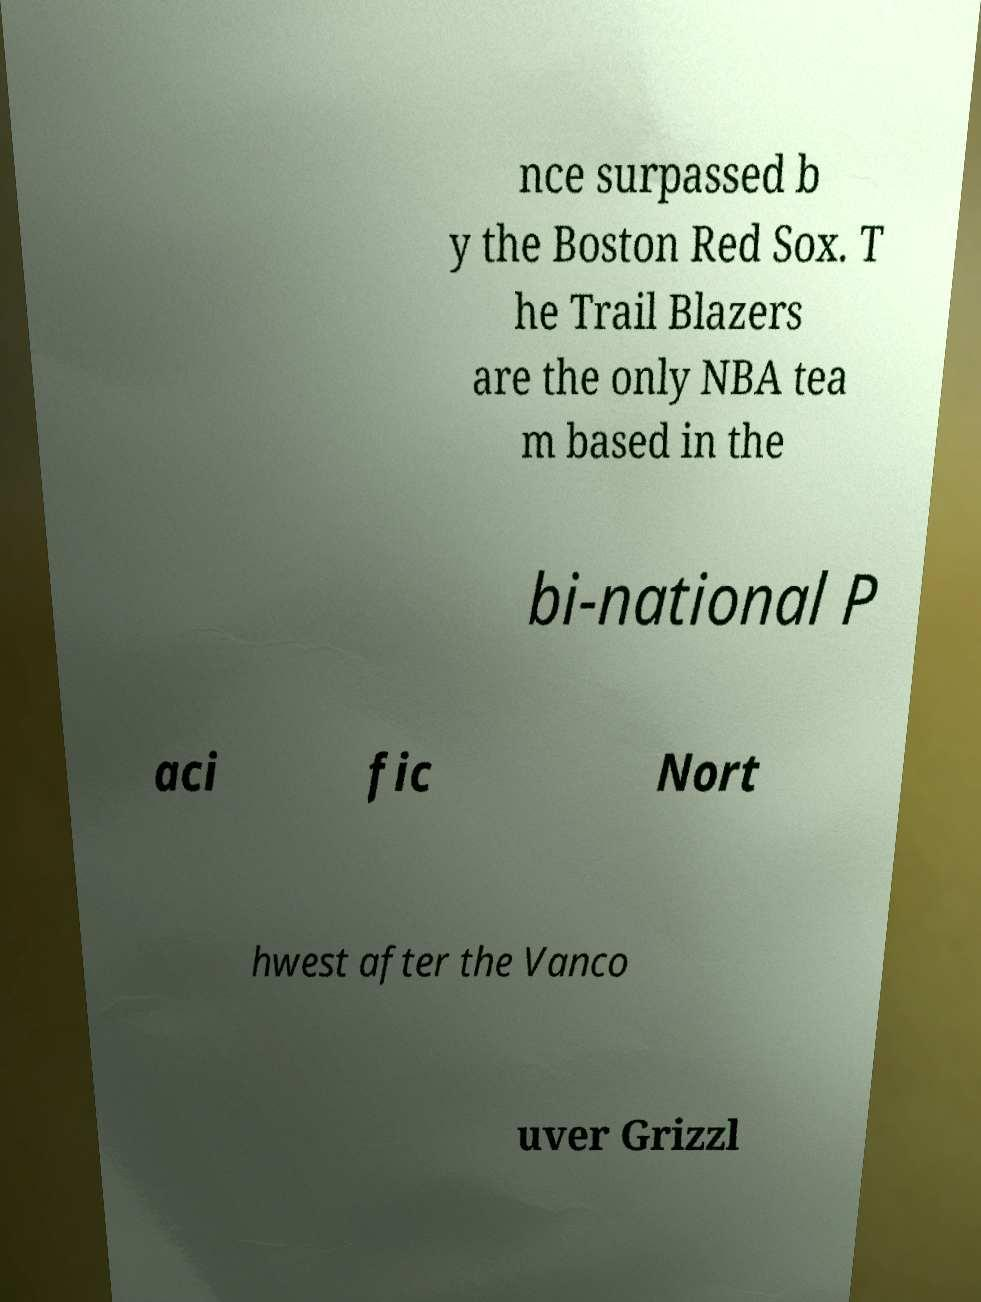What messages or text are displayed in this image? I need them in a readable, typed format. nce surpassed b y the Boston Red Sox. T he Trail Blazers are the only NBA tea m based in the bi-national P aci fic Nort hwest after the Vanco uver Grizzl 